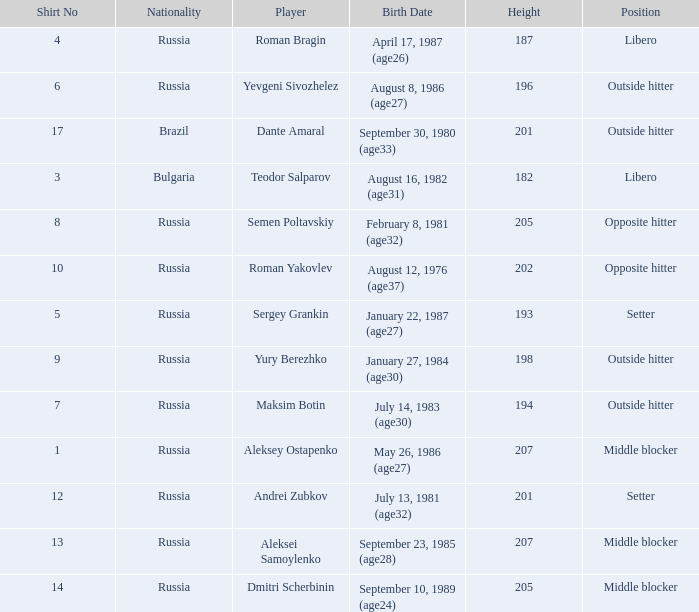How tall is Maksim Botin?  194.0. 